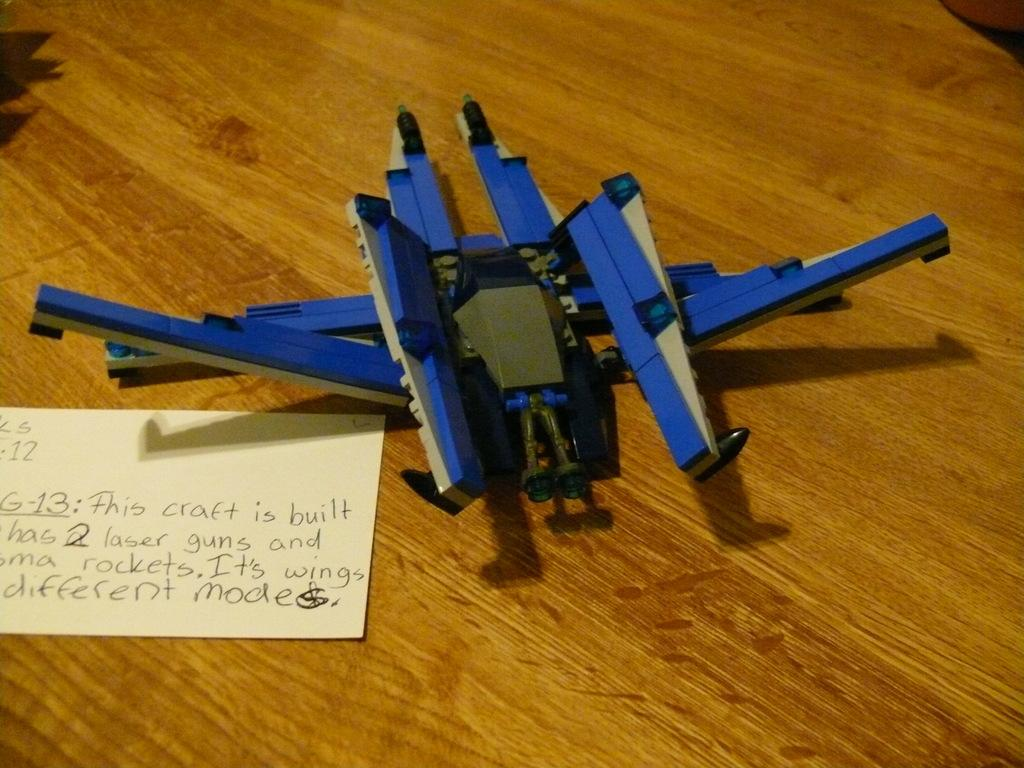What type of material is visible in the image? There is paper in the image. What else can be seen in the image besides the paper? There is an object and a wooden-made thing present in the image. Where is the dock located in the image? There is no dock present in the image. What type of worm can be seen crawling on the wooden-made thing in the image? There are no worms present in the image. 